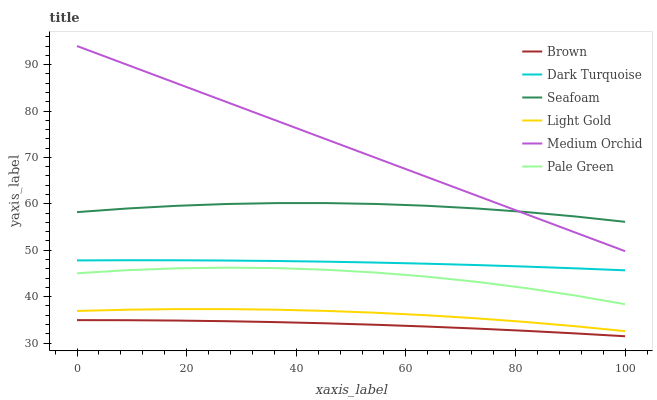Does Brown have the minimum area under the curve?
Answer yes or no. Yes. Does Medium Orchid have the maximum area under the curve?
Answer yes or no. Yes. Does Dark Turquoise have the minimum area under the curve?
Answer yes or no. No. Does Dark Turquoise have the maximum area under the curve?
Answer yes or no. No. Is Medium Orchid the smoothest?
Answer yes or no. Yes. Is Pale Green the roughest?
Answer yes or no. Yes. Is Dark Turquoise the smoothest?
Answer yes or no. No. Is Dark Turquoise the roughest?
Answer yes or no. No. Does Brown have the lowest value?
Answer yes or no. Yes. Does Dark Turquoise have the lowest value?
Answer yes or no. No. Does Medium Orchid have the highest value?
Answer yes or no. Yes. Does Dark Turquoise have the highest value?
Answer yes or no. No. Is Dark Turquoise less than Seafoam?
Answer yes or no. Yes. Is Medium Orchid greater than Brown?
Answer yes or no. Yes. Does Seafoam intersect Medium Orchid?
Answer yes or no. Yes. Is Seafoam less than Medium Orchid?
Answer yes or no. No. Is Seafoam greater than Medium Orchid?
Answer yes or no. No. Does Dark Turquoise intersect Seafoam?
Answer yes or no. No. 